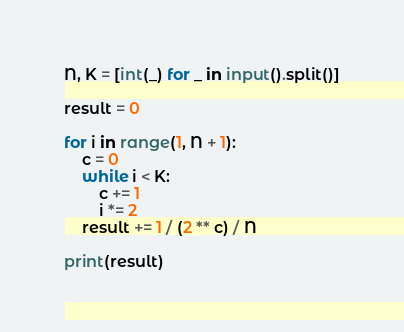Convert code to text. <code><loc_0><loc_0><loc_500><loc_500><_Python_>N, K = [int(_) for _ in input().split()]

result = 0

for i in range(1, N + 1):
    c = 0
    while i < K:
        c += 1
        i *= 2
    result += 1 / (2 ** c) / N

print(result)
</code> 